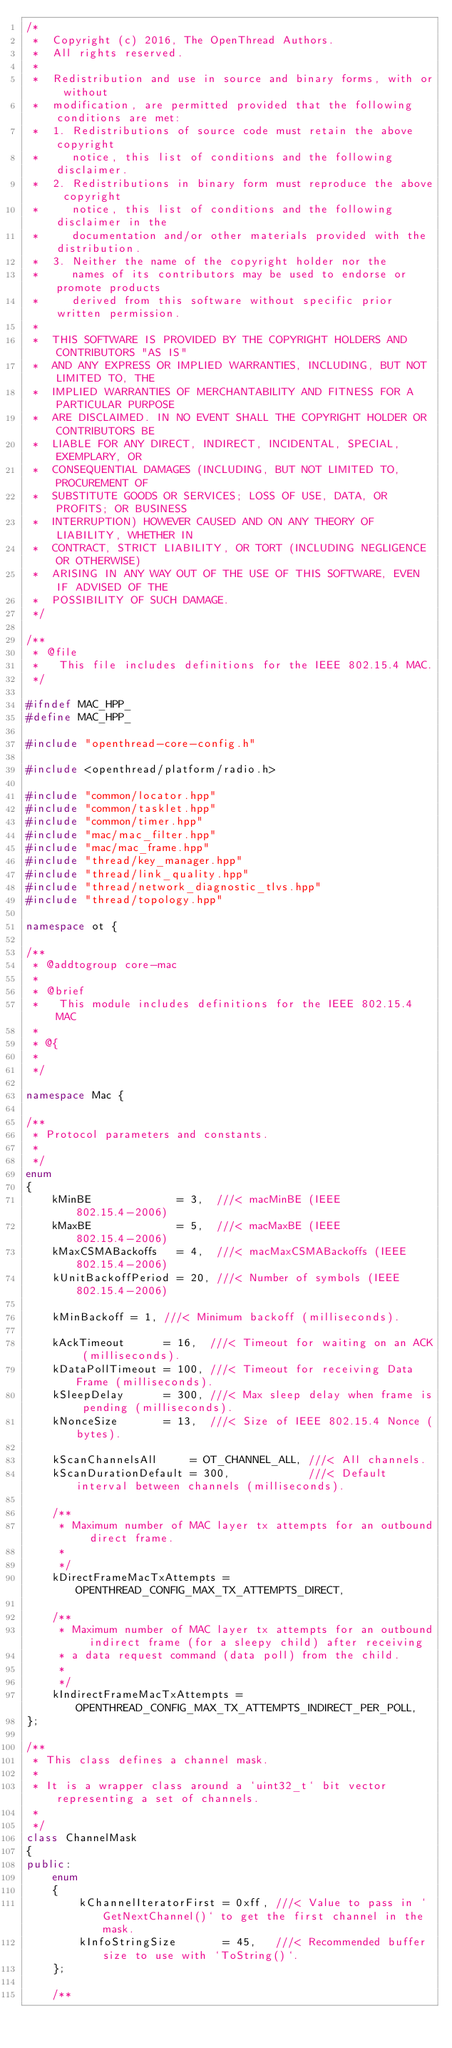<code> <loc_0><loc_0><loc_500><loc_500><_C++_>/*
 *  Copyright (c) 2016, The OpenThread Authors.
 *  All rights reserved.
 *
 *  Redistribution and use in source and binary forms, with or without
 *  modification, are permitted provided that the following conditions are met:
 *  1. Redistributions of source code must retain the above copyright
 *     notice, this list of conditions and the following disclaimer.
 *  2. Redistributions in binary form must reproduce the above copyright
 *     notice, this list of conditions and the following disclaimer in the
 *     documentation and/or other materials provided with the distribution.
 *  3. Neither the name of the copyright holder nor the
 *     names of its contributors may be used to endorse or promote products
 *     derived from this software without specific prior written permission.
 *
 *  THIS SOFTWARE IS PROVIDED BY THE COPYRIGHT HOLDERS AND CONTRIBUTORS "AS IS"
 *  AND ANY EXPRESS OR IMPLIED WARRANTIES, INCLUDING, BUT NOT LIMITED TO, THE
 *  IMPLIED WARRANTIES OF MERCHANTABILITY AND FITNESS FOR A PARTICULAR PURPOSE
 *  ARE DISCLAIMED. IN NO EVENT SHALL THE COPYRIGHT HOLDER OR CONTRIBUTORS BE
 *  LIABLE FOR ANY DIRECT, INDIRECT, INCIDENTAL, SPECIAL, EXEMPLARY, OR
 *  CONSEQUENTIAL DAMAGES (INCLUDING, BUT NOT LIMITED TO, PROCUREMENT OF
 *  SUBSTITUTE GOODS OR SERVICES; LOSS OF USE, DATA, OR PROFITS; OR BUSINESS
 *  INTERRUPTION) HOWEVER CAUSED AND ON ANY THEORY OF LIABILITY, WHETHER IN
 *  CONTRACT, STRICT LIABILITY, OR TORT (INCLUDING NEGLIGENCE OR OTHERWISE)
 *  ARISING IN ANY WAY OUT OF THE USE OF THIS SOFTWARE, EVEN IF ADVISED OF THE
 *  POSSIBILITY OF SUCH DAMAGE.
 */

/**
 * @file
 *   This file includes definitions for the IEEE 802.15.4 MAC.
 */

#ifndef MAC_HPP_
#define MAC_HPP_

#include "openthread-core-config.h"

#include <openthread/platform/radio.h>

#include "common/locator.hpp"
#include "common/tasklet.hpp"
#include "common/timer.hpp"
#include "mac/mac_filter.hpp"
#include "mac/mac_frame.hpp"
#include "thread/key_manager.hpp"
#include "thread/link_quality.hpp"
#include "thread/network_diagnostic_tlvs.hpp"
#include "thread/topology.hpp"

namespace ot {

/**
 * @addtogroup core-mac
 *
 * @brief
 *   This module includes definitions for the IEEE 802.15.4 MAC
 *
 * @{
 *
 */

namespace Mac {

/**
 * Protocol parameters and constants.
 *
 */
enum
{
    kMinBE             = 3,  ///< macMinBE (IEEE 802.15.4-2006)
    kMaxBE             = 5,  ///< macMaxBE (IEEE 802.15.4-2006)
    kMaxCSMABackoffs   = 4,  ///< macMaxCSMABackoffs (IEEE 802.15.4-2006)
    kUnitBackoffPeriod = 20, ///< Number of symbols (IEEE 802.15.4-2006)

    kMinBackoff = 1, ///< Minimum backoff (milliseconds).

    kAckTimeout      = 16,  ///< Timeout for waiting on an ACK (milliseconds).
    kDataPollTimeout = 100, ///< Timeout for receiving Data Frame (milliseconds).
    kSleepDelay      = 300, ///< Max sleep delay when frame is pending (milliseconds).
    kNonceSize       = 13,  ///< Size of IEEE 802.15.4 Nonce (bytes).

    kScanChannelsAll     = OT_CHANNEL_ALL, ///< All channels.
    kScanDurationDefault = 300,            ///< Default interval between channels (milliseconds).

    /**
     * Maximum number of MAC layer tx attempts for an outbound direct frame.
     *
     */
    kDirectFrameMacTxAttempts = OPENTHREAD_CONFIG_MAX_TX_ATTEMPTS_DIRECT,

    /**
     * Maximum number of MAC layer tx attempts for an outbound indirect frame (for a sleepy child) after receiving
     * a data request command (data poll) from the child.
     *
     */
    kIndirectFrameMacTxAttempts = OPENTHREAD_CONFIG_MAX_TX_ATTEMPTS_INDIRECT_PER_POLL,
};

/**
 * This class defines a channel mask.
 *
 * It is a wrapper class around a `uint32_t` bit vector representing a set of channels.
 *
 */
class ChannelMask
{
public:
    enum
    {
        kChannelIteratorFirst = 0xff, ///< Value to pass in `GetNextChannel()` to get the first channel in the mask.
        kInfoStringSize       = 45,   ///< Recommended buffer size to use with `ToString()`.
    };

    /**</code> 